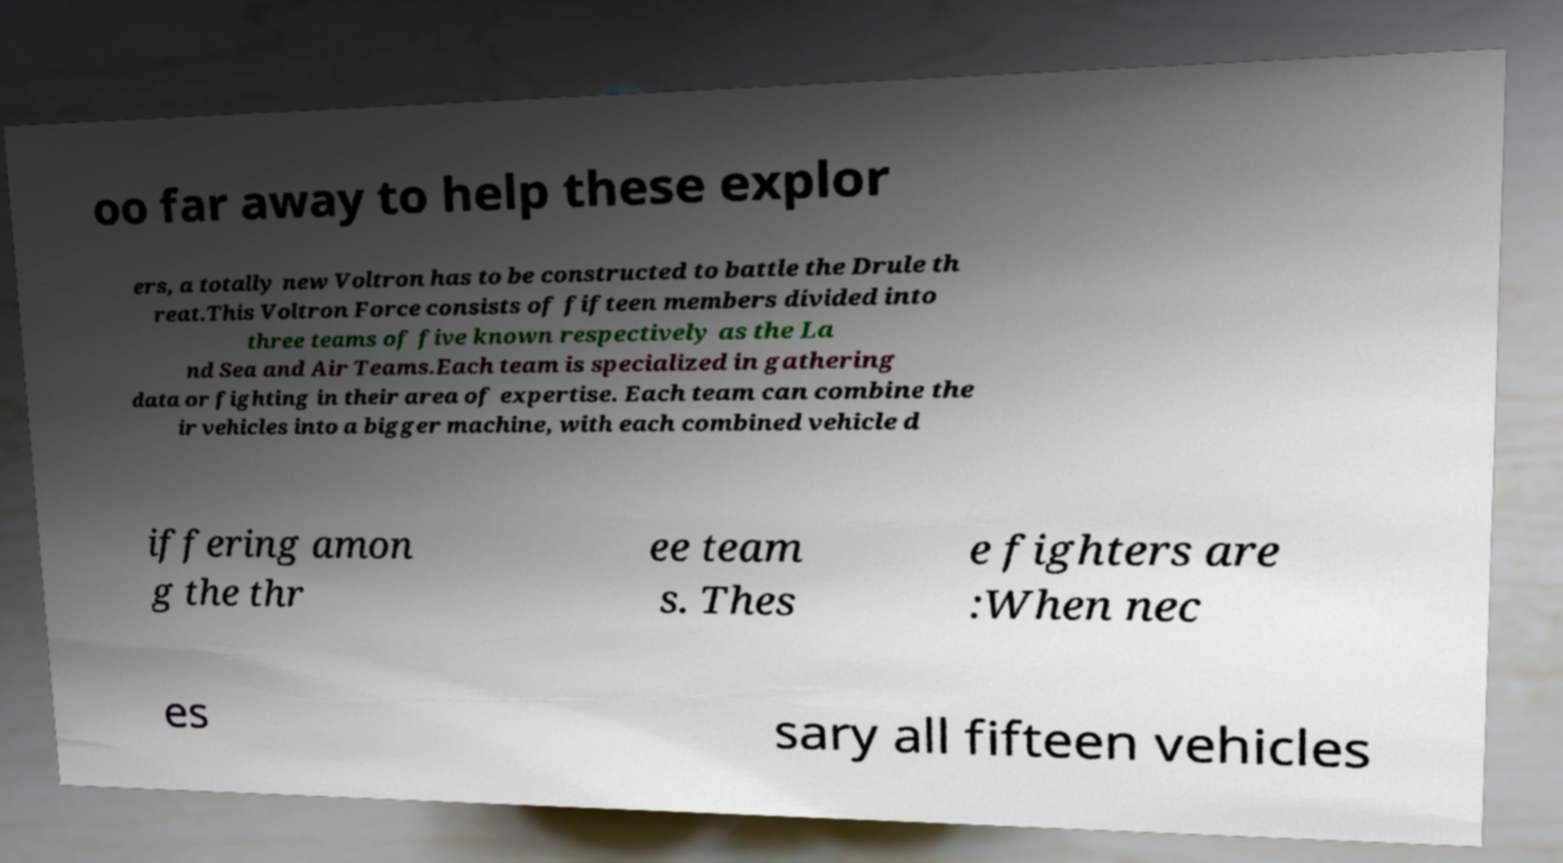Please read and relay the text visible in this image. What does it say? oo far away to help these explor ers, a totally new Voltron has to be constructed to battle the Drule th reat.This Voltron Force consists of fifteen members divided into three teams of five known respectively as the La nd Sea and Air Teams.Each team is specialized in gathering data or fighting in their area of expertise. Each team can combine the ir vehicles into a bigger machine, with each combined vehicle d iffering amon g the thr ee team s. Thes e fighters are :When nec es sary all fifteen vehicles 